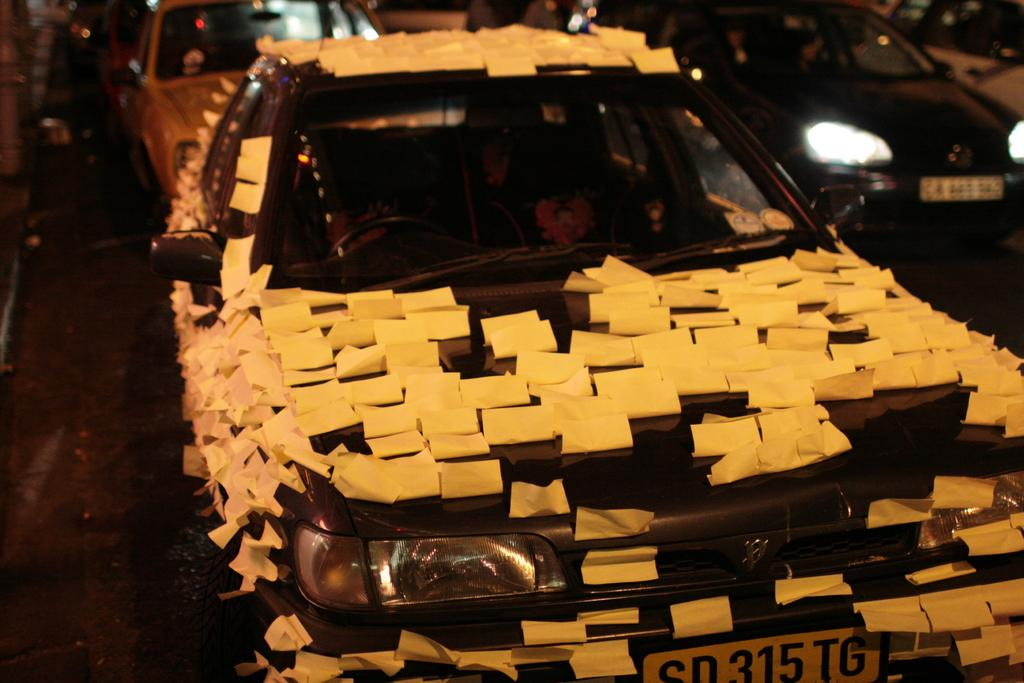What is the main subject in the front of the image? There is a car in the front of the image. Are there any distinguishing features on the car? Yes, the car has stickers on it. What else can be seen in the image related to cars? There are cars visible in the background of the image. What news story is being discussed by the cars in the image? There is no indication in the image that the cars are discussing any news stories. 